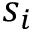<formula> <loc_0><loc_0><loc_500><loc_500>s _ { i }</formula> 